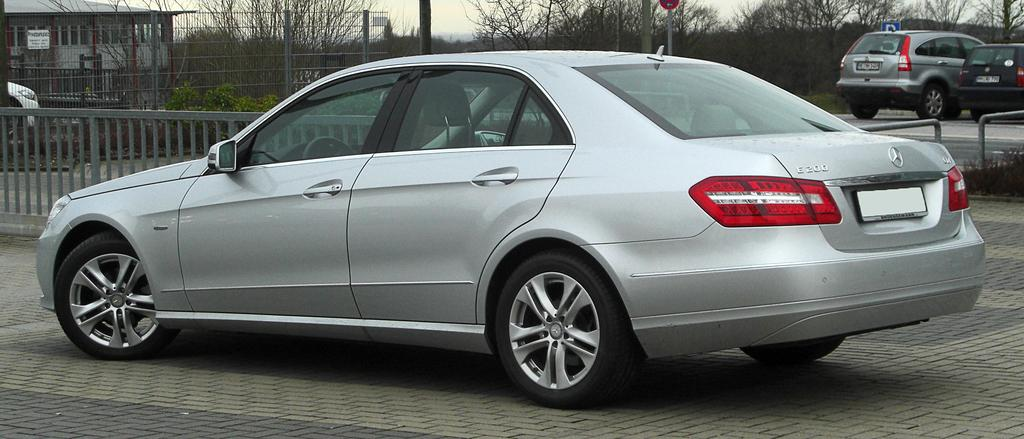What can be seen on the road in the image? There are vehicles on the road in the image. What is the purpose of the fence in the image? The fence in the image serves as a boundary or barrier. What type of natural elements can be seen in the background of the image? There are trees in the background of the image. What type of man-made structures can be seen in the background of the image? There is at least one building and a sign board in the background of the image. What other objects can be seen in the background of the image? There are poles in the background of the image. What type of stage can be seen in the image? There is no stage present in the image. Is there a scarf hanging from the fence in the image? There is no scarf visible in the image. 